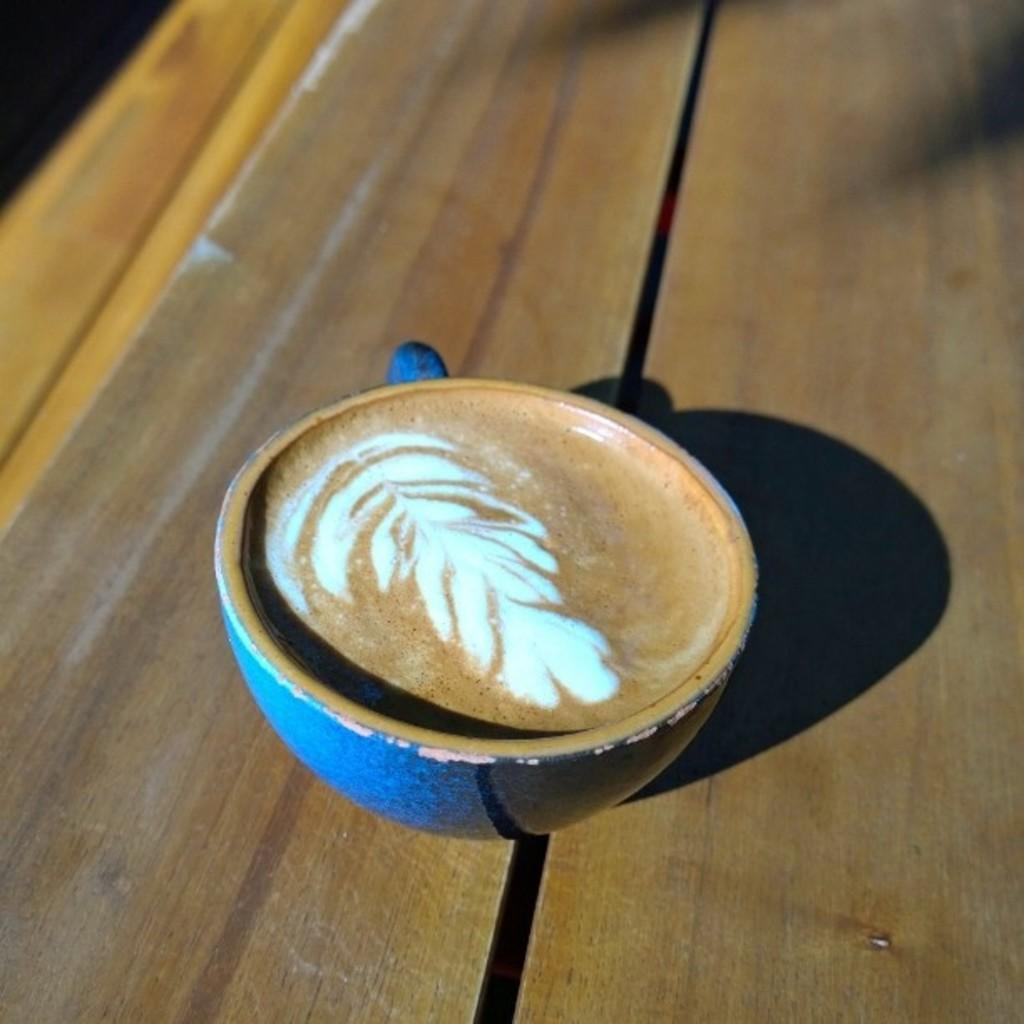What type of surface is visible in the image? There is a wooden surface in the image. What object is placed on the wooden surface? There is a cup on the wooden surface. What is inside the cup? The cup contains a liquid. What type of cream can be seen being whipped in the image? There is no cream or whipping action present in the image; it only features a wooden surface with a cup containing a liquid. 